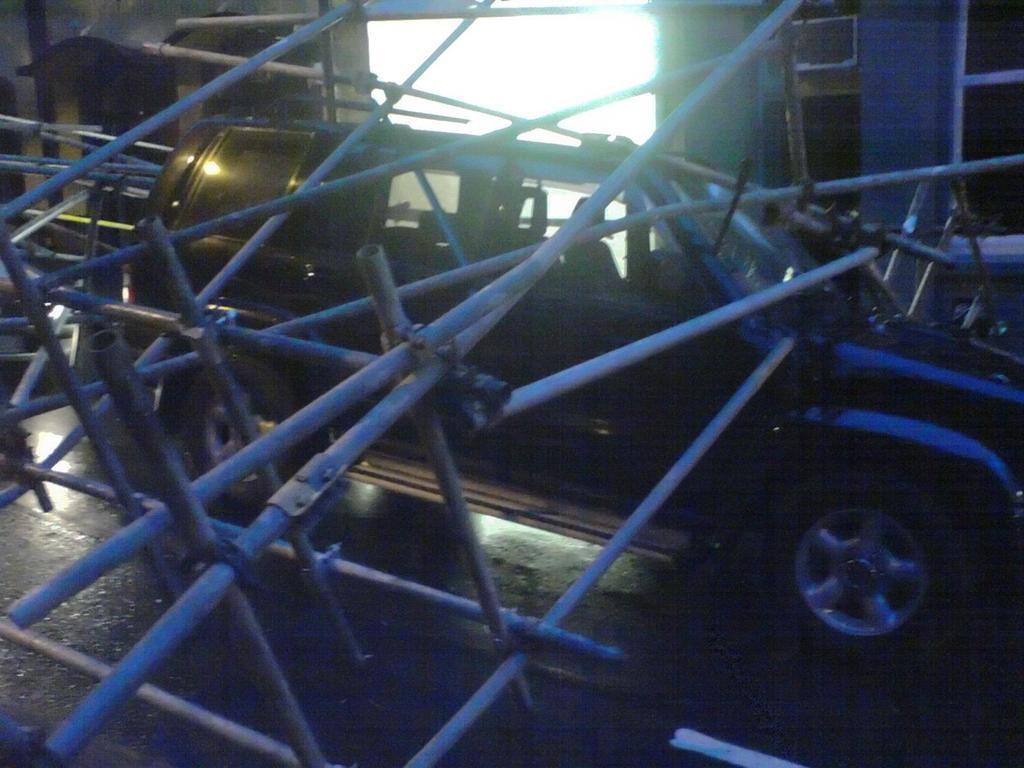Describe this image in one or two sentences. In this image in the front there are rods. In the center there is a car which is black in colour. In the background there is wall and there are windows. 